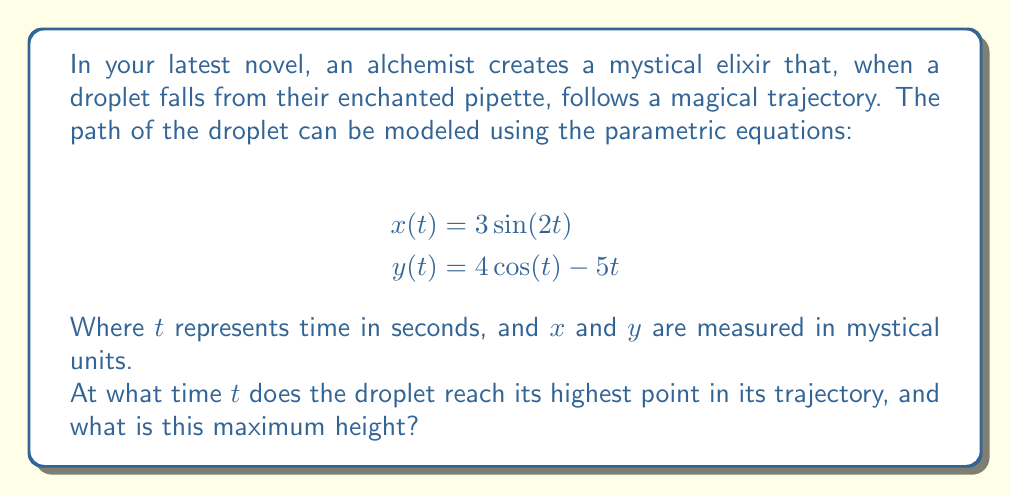Can you solve this math problem? To solve this problem, we need to follow these steps:

1) The highest point of the trajectory occurs when the y-coordinate reaches its maximum value. This happens when the vertical velocity is zero.

2) To find the vertical velocity, we need to differentiate $y(t)$ with respect to $t$:

   $$\frac{dy}{dt} = -4\sin(t) - 5$$

3) Set this equal to zero to find when the vertical velocity is zero:

   $$-4\sin(t) - 5 = 0$$
   $$-4\sin(t) = 5$$
   $$\sin(t) = -\frac{5}{4}$$

4) To solve this, we need to use the arcsine function:

   $$t = \arcsin(-\frac{5}{4}) + 2\pi n$$

   Where $n$ is an integer. Since we're dealing with the first cycle of the motion, we can take $n=0$.

5) Using a calculator or computer, we can find:

   $$t \approx 4.5752 \text{ seconds}$$

6) Now that we know the time, we can find the maximum height by plugging this value of $t$ back into the equation for $y(t)$:

   $$y(4.5752) = 4\cos(4.5752) - 5(4.5752)$$

7) Calculating this gives us:

   $$y(4.5752) \approx 1.6439 \text{ mystical units}$$

This is the maximum height reached by the droplet.
Answer: The droplet reaches its highest point at approximately $t = 4.5752$ seconds, and the maximum height is approximately $1.6439$ mystical units. 